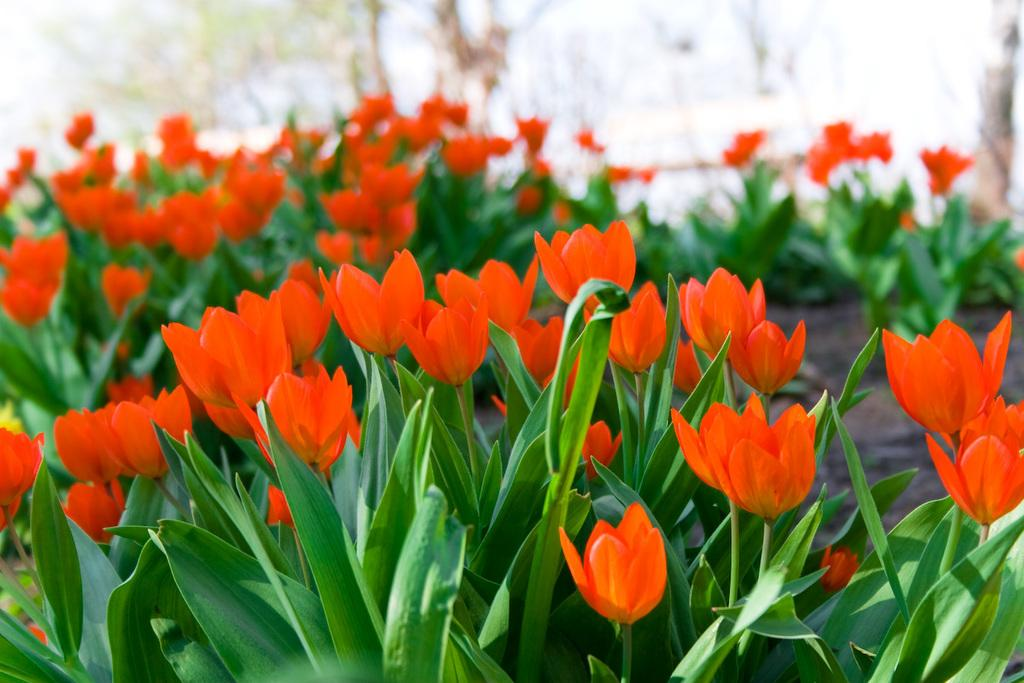What type of flowers can be seen in the image? There is a tulip flower garden in the image. What color are the leaves of the tulip flowers? The tulip flowers have green leaves. What type of sticks are used to make the cream in the image? There is no mention of sticks or cream in the image; it features a tulip flower garden with green-leaved tulips. 